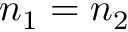Convert formula to latex. <formula><loc_0><loc_0><loc_500><loc_500>n _ { 1 } = n _ { 2 }</formula> 